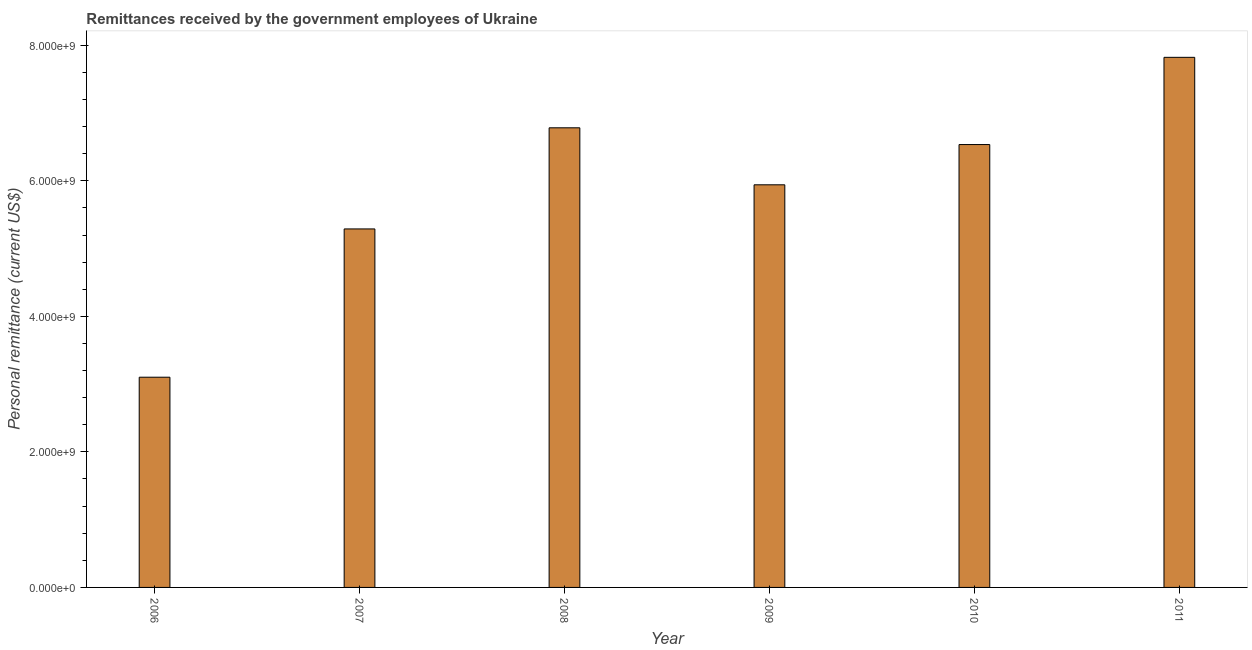Does the graph contain any zero values?
Your answer should be very brief. No. What is the title of the graph?
Your response must be concise. Remittances received by the government employees of Ukraine. What is the label or title of the Y-axis?
Provide a succinct answer. Personal remittance (current US$). What is the personal remittances in 2006?
Offer a terse response. 3.10e+09. Across all years, what is the maximum personal remittances?
Your answer should be compact. 7.82e+09. Across all years, what is the minimum personal remittances?
Provide a succinct answer. 3.10e+09. In which year was the personal remittances minimum?
Provide a succinct answer. 2006. What is the sum of the personal remittances?
Give a very brief answer. 3.55e+1. What is the difference between the personal remittances in 2006 and 2011?
Keep it short and to the point. -4.72e+09. What is the average personal remittances per year?
Provide a short and direct response. 5.91e+09. What is the median personal remittances?
Your response must be concise. 6.24e+09. What is the ratio of the personal remittances in 2006 to that in 2011?
Make the answer very short. 0.4. Is the personal remittances in 2008 less than that in 2009?
Your response must be concise. No. What is the difference between the highest and the second highest personal remittances?
Make the answer very short. 1.04e+09. Is the sum of the personal remittances in 2007 and 2009 greater than the maximum personal remittances across all years?
Provide a short and direct response. Yes. What is the difference between the highest and the lowest personal remittances?
Offer a terse response. 4.72e+09. In how many years, is the personal remittances greater than the average personal remittances taken over all years?
Ensure brevity in your answer.  4. How many bars are there?
Give a very brief answer. 6. Are all the bars in the graph horizontal?
Keep it short and to the point. No. How many years are there in the graph?
Your answer should be compact. 6. What is the Personal remittance (current US$) in 2006?
Provide a short and direct response. 3.10e+09. What is the Personal remittance (current US$) in 2007?
Offer a terse response. 5.29e+09. What is the Personal remittance (current US$) of 2008?
Give a very brief answer. 6.78e+09. What is the Personal remittance (current US$) of 2009?
Your answer should be compact. 5.94e+09. What is the Personal remittance (current US$) of 2010?
Provide a succinct answer. 6.54e+09. What is the Personal remittance (current US$) in 2011?
Your answer should be compact. 7.82e+09. What is the difference between the Personal remittance (current US$) in 2006 and 2007?
Your response must be concise. -2.19e+09. What is the difference between the Personal remittance (current US$) in 2006 and 2008?
Offer a terse response. -3.68e+09. What is the difference between the Personal remittance (current US$) in 2006 and 2009?
Provide a short and direct response. -2.84e+09. What is the difference between the Personal remittance (current US$) in 2006 and 2010?
Your answer should be very brief. -3.43e+09. What is the difference between the Personal remittance (current US$) in 2006 and 2011?
Offer a very short reply. -4.72e+09. What is the difference between the Personal remittance (current US$) in 2007 and 2008?
Your response must be concise. -1.49e+09. What is the difference between the Personal remittance (current US$) in 2007 and 2009?
Keep it short and to the point. -6.51e+08. What is the difference between the Personal remittance (current US$) in 2007 and 2010?
Your answer should be very brief. -1.24e+09. What is the difference between the Personal remittance (current US$) in 2007 and 2011?
Provide a succinct answer. -2.53e+09. What is the difference between the Personal remittance (current US$) in 2008 and 2009?
Your answer should be very brief. 8.41e+08. What is the difference between the Personal remittance (current US$) in 2008 and 2010?
Provide a succinct answer. 2.47e+08. What is the difference between the Personal remittance (current US$) in 2008 and 2011?
Offer a very short reply. -1.04e+09. What is the difference between the Personal remittance (current US$) in 2009 and 2010?
Provide a short and direct response. -5.94e+08. What is the difference between the Personal remittance (current US$) in 2009 and 2011?
Your response must be concise. -1.88e+09. What is the difference between the Personal remittance (current US$) in 2010 and 2011?
Provide a short and direct response. -1.29e+09. What is the ratio of the Personal remittance (current US$) in 2006 to that in 2007?
Make the answer very short. 0.59. What is the ratio of the Personal remittance (current US$) in 2006 to that in 2008?
Offer a very short reply. 0.46. What is the ratio of the Personal remittance (current US$) in 2006 to that in 2009?
Offer a terse response. 0.52. What is the ratio of the Personal remittance (current US$) in 2006 to that in 2010?
Provide a succinct answer. 0.47. What is the ratio of the Personal remittance (current US$) in 2006 to that in 2011?
Make the answer very short. 0.4. What is the ratio of the Personal remittance (current US$) in 2007 to that in 2008?
Ensure brevity in your answer.  0.78. What is the ratio of the Personal remittance (current US$) in 2007 to that in 2009?
Provide a short and direct response. 0.89. What is the ratio of the Personal remittance (current US$) in 2007 to that in 2010?
Make the answer very short. 0.81. What is the ratio of the Personal remittance (current US$) in 2007 to that in 2011?
Give a very brief answer. 0.68. What is the ratio of the Personal remittance (current US$) in 2008 to that in 2009?
Provide a short and direct response. 1.14. What is the ratio of the Personal remittance (current US$) in 2008 to that in 2010?
Give a very brief answer. 1.04. What is the ratio of the Personal remittance (current US$) in 2008 to that in 2011?
Your response must be concise. 0.87. What is the ratio of the Personal remittance (current US$) in 2009 to that in 2010?
Give a very brief answer. 0.91. What is the ratio of the Personal remittance (current US$) in 2009 to that in 2011?
Your answer should be very brief. 0.76. What is the ratio of the Personal remittance (current US$) in 2010 to that in 2011?
Make the answer very short. 0.83. 